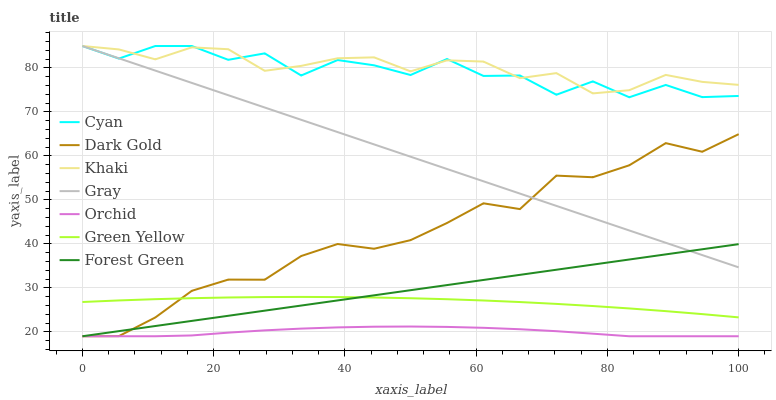Does Orchid have the minimum area under the curve?
Answer yes or no. Yes. Does Khaki have the maximum area under the curve?
Answer yes or no. Yes. Does Dark Gold have the minimum area under the curve?
Answer yes or no. No. Does Dark Gold have the maximum area under the curve?
Answer yes or no. No. Is Forest Green the smoothest?
Answer yes or no. Yes. Is Cyan the roughest?
Answer yes or no. Yes. Is Khaki the smoothest?
Answer yes or no. No. Is Khaki the roughest?
Answer yes or no. No. Does Dark Gold have the lowest value?
Answer yes or no. Yes. Does Khaki have the lowest value?
Answer yes or no. No. Does Cyan have the highest value?
Answer yes or no. Yes. Does Dark Gold have the highest value?
Answer yes or no. No. Is Orchid less than Gray?
Answer yes or no. Yes. Is Cyan greater than Green Yellow?
Answer yes or no. Yes. Does Forest Green intersect Dark Gold?
Answer yes or no. Yes. Is Forest Green less than Dark Gold?
Answer yes or no. No. Is Forest Green greater than Dark Gold?
Answer yes or no. No. Does Orchid intersect Gray?
Answer yes or no. No. 